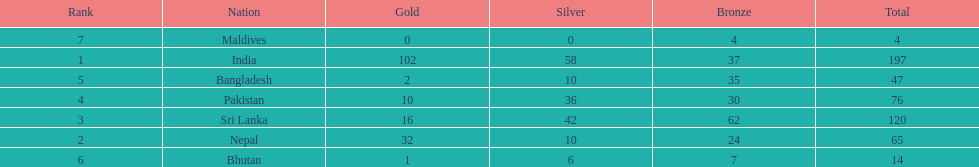How many gold medals did india win? 102. 